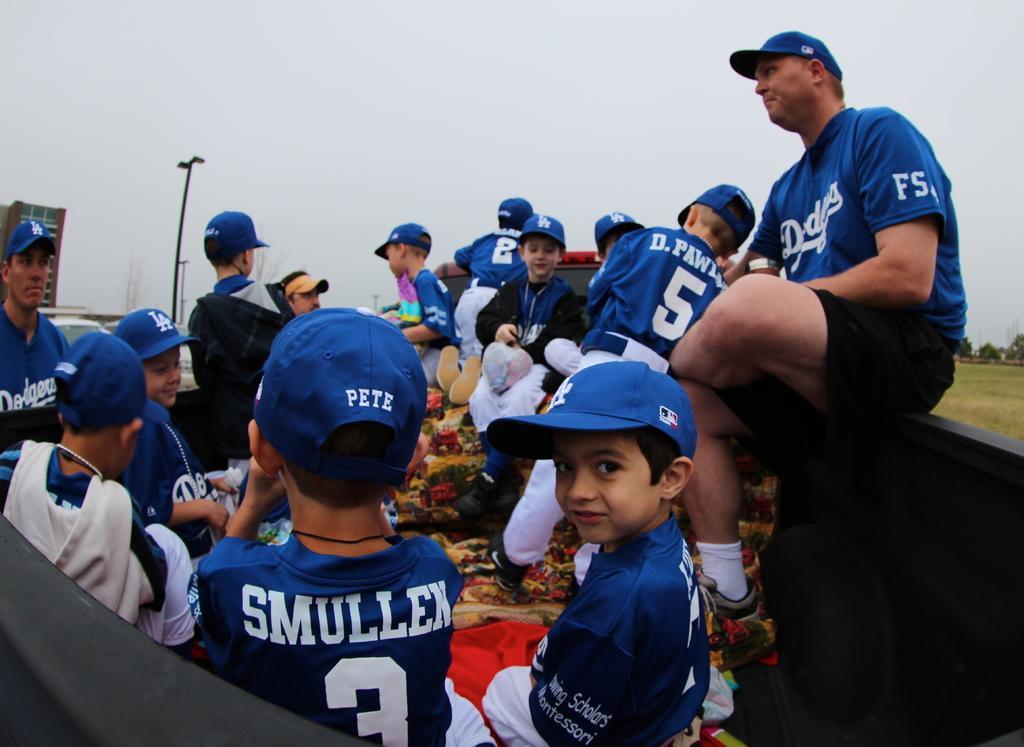Can you describe this image briefly? In this image there are some boys and some persons and they are sitting in a vehicle, and also there are some objects. In the background there are some buildings, trees, poles. At the top there is sky, and on the right side there is grass. 